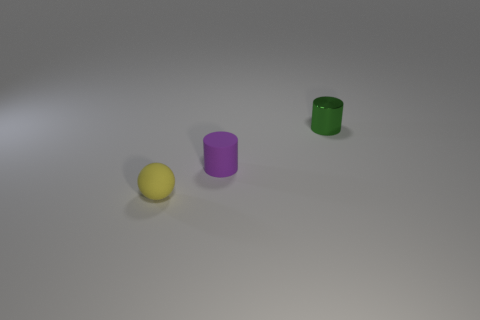What can you infer about the setting of these objects? The setting appears to be a neutral, possibly artificial environment as indicated by the uniform background. The lighting suggests an indoor scene with a soft, diffused light source from above. 